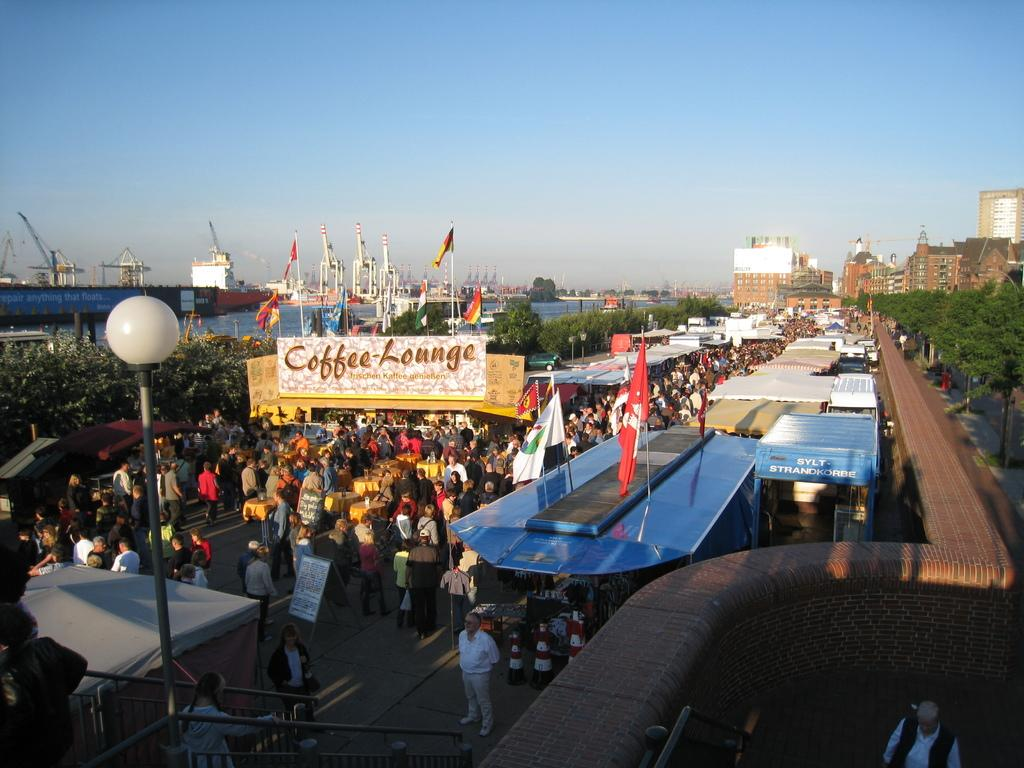How many people can be seen in the image? There are people in the image. What objects are present in the image that are related to sports or games? There are boards, flags, poles, traffic cones, and stalls in the image. What structures can be seen in the image that might provide boundaries or enclosures? There is a fence, a wall, and buildings in the image. What natural elements are visible in the image? There are trees and water visible in the image. What part of the natural environment can be seen in the background of the image? The sky is visible in the background of the image. Can you tell me where the self is located in the image? There is no self present in the image, as it refers to a person's identity or sense of self, which cannot be seen in a photograph. What type of spot is visible on the ground in the image? There is no specific spot mentioned or visible in the image; it is a general term that could refer to various types of marks or areas. 